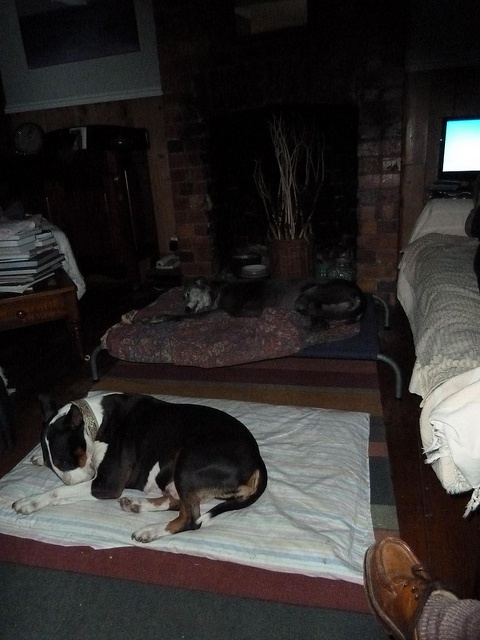Describe the objects in this image and their specific colors. I can see dog in black, darkgray, and gray tones, bed in black, gray, lightgray, and darkgray tones, bed in black and gray tones, people in black, maroon, and gray tones, and dog in black and gray tones in this image. 